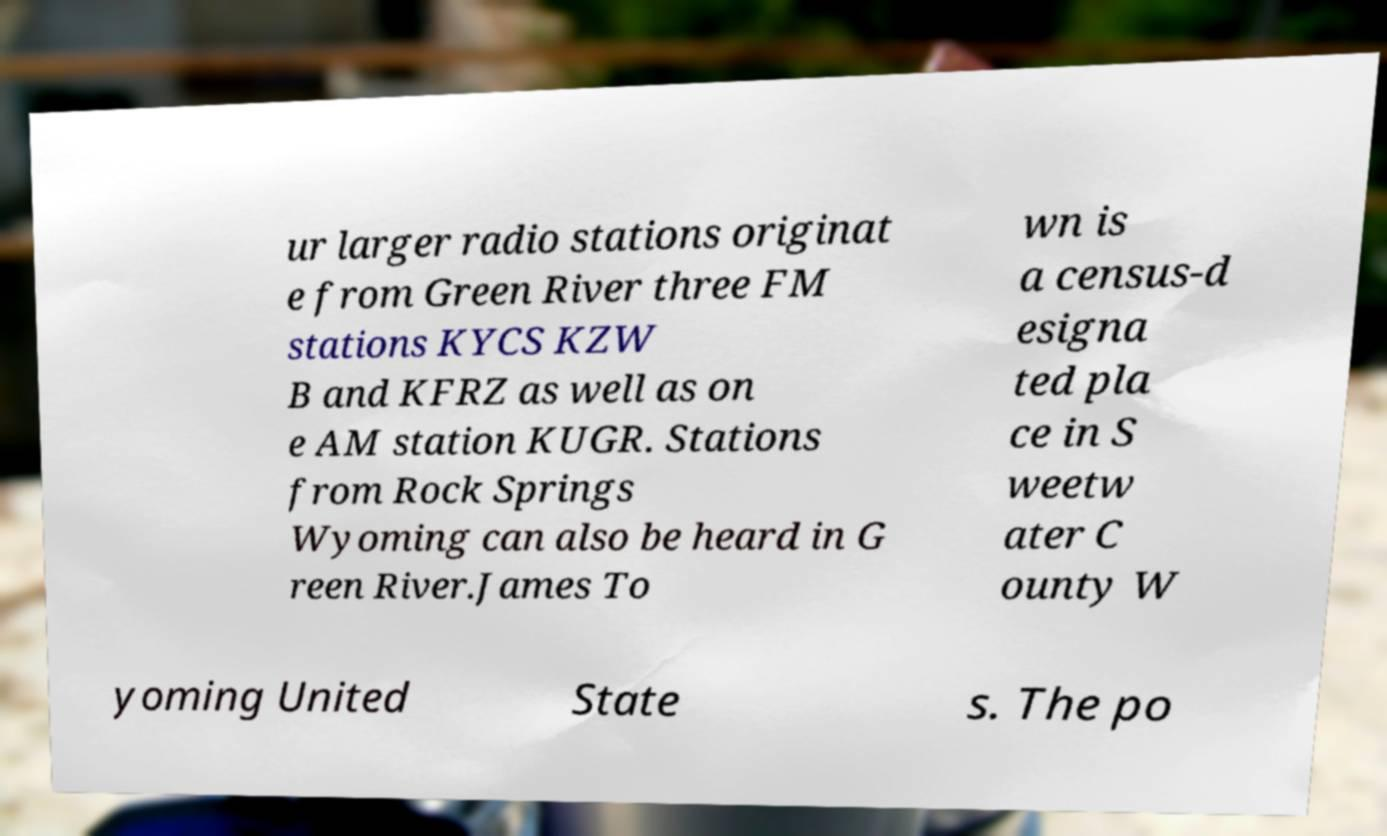For documentation purposes, I need the text within this image transcribed. Could you provide that? ur larger radio stations originat e from Green River three FM stations KYCS KZW B and KFRZ as well as on e AM station KUGR. Stations from Rock Springs Wyoming can also be heard in G reen River.James To wn is a census-d esigna ted pla ce in S weetw ater C ounty W yoming United State s. The po 